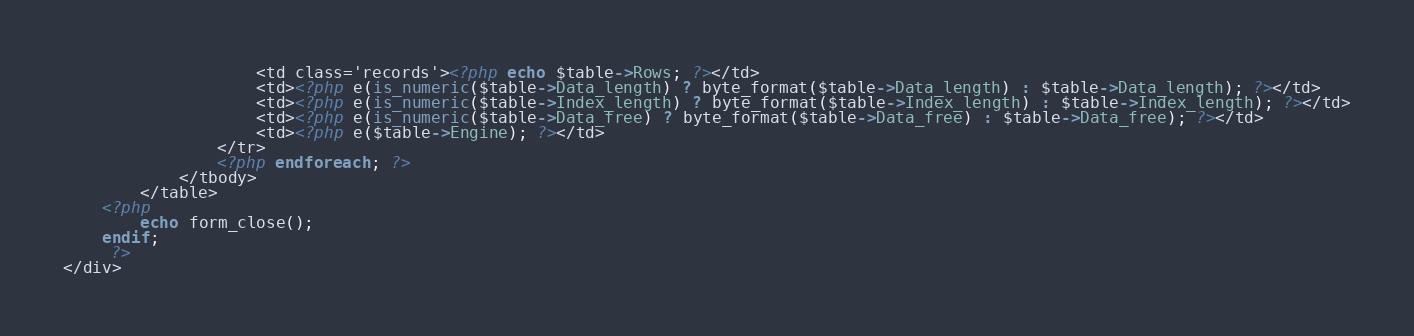<code> <loc_0><loc_0><loc_500><loc_500><_PHP_>					<td class='records'><?php echo $table->Rows; ?></td>
                    <td><?php e(is_numeric($table->Data_length) ? byte_format($table->Data_length) : $table->Data_length); ?></td>
                    <td><?php e(is_numeric($table->Index_length) ? byte_format($table->Index_length) : $table->Index_length); ?></td>
                    <td><?php e(is_numeric($table->Data_free) ? byte_format($table->Data_free) : $table->Data_free); ?></td>
                    <td><?php e($table->Engine); ?></td>
				</tr>
				<?php endforeach; ?>
			</tbody>
		</table>
	<?php 
		echo form_close();
    endif;
	 ?>
</div></code> 